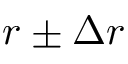Convert formula to latex. <formula><loc_0><loc_0><loc_500><loc_500>r \pm \Delta r</formula> 